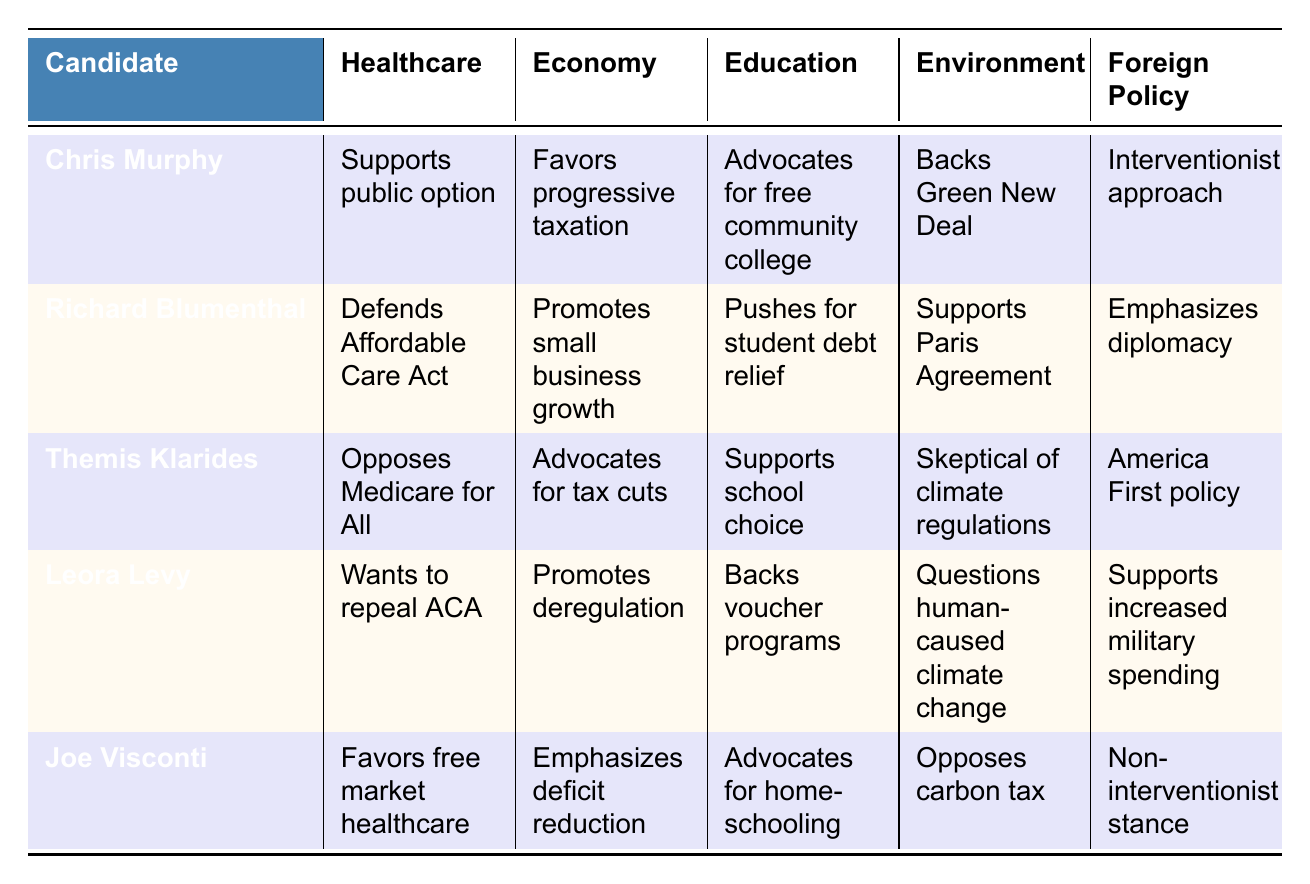What healthcare position does Chris Murphy support? The table indicates that Chris Murphy supports a public option for healthcare.
Answer: Supports public option Which candidate promotes small business growth? According to the table, Richard Blumenthal promotes small business growth.
Answer: Richard Blumenthal Does Themis Klarides support Medicare for All? The table shows that Themis Klarides opposes Medicare for All.
Answer: No Who is the most interventionist in foreign policy? Chris Murphy is listed with an interventionist approach, while others like Joe Visconti take a non-interventionist stance. Therefore, Chris Murphy has the most interventionist approach.
Answer: Chris Murphy What are the education positions of candidates opposing the ACA? Leora Levy wants to repeal the ACA and backs voucher programs, while Chris Murphy supports free community college. Therefore, opposition to the ACA relates to Leora Levy.
Answer: Leora Levy Which candidate has the lowest environmental concern? Leora Levy questions human-caused climate change and supports deregulation, implying lower concern for environmental policies compared to others who back regulations.
Answer: Leora Levy Summarize the foreign policy positions of the candidates. Chris Murphy and Richard Blumenthal seek interventions through diplomacy, while Themis Klarides, Leora Levy, and Joe Visconti take more conservative stances with a focus on military spending or non-intervention.
Answer: Chris Murphy and Richard Blumenthal favor intervention; the others do not How many candidates support the Paris Agreement? Only Richard Blumenthal is noted as supporting the Paris Agreement according to the table.
Answer: One candidate Which candidate has a total of three positions on public education? The number of education positions is three: Themis Klarides supports school choice, Leora Levy backs voucher programs, and Joe Visconti advocates for homeschooling. Therefore, three candidates have different positions.
Answer: Three candidates Based on their environmental policies, who is the most aligned with climate action initiatives? Chris Murphy and Richard Blumenthal support climate action initiatives, such as the Green New Deal and the Paris Agreement, while others show skepticism or outright opposition.
Answer: Chris Murphy and Richard Blumenthal 